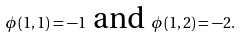<formula> <loc_0><loc_0><loc_500><loc_500>\phi ( 1 , 1 ) = - 1 \text { and } \phi ( 1 , 2 ) = - 2 .</formula> 